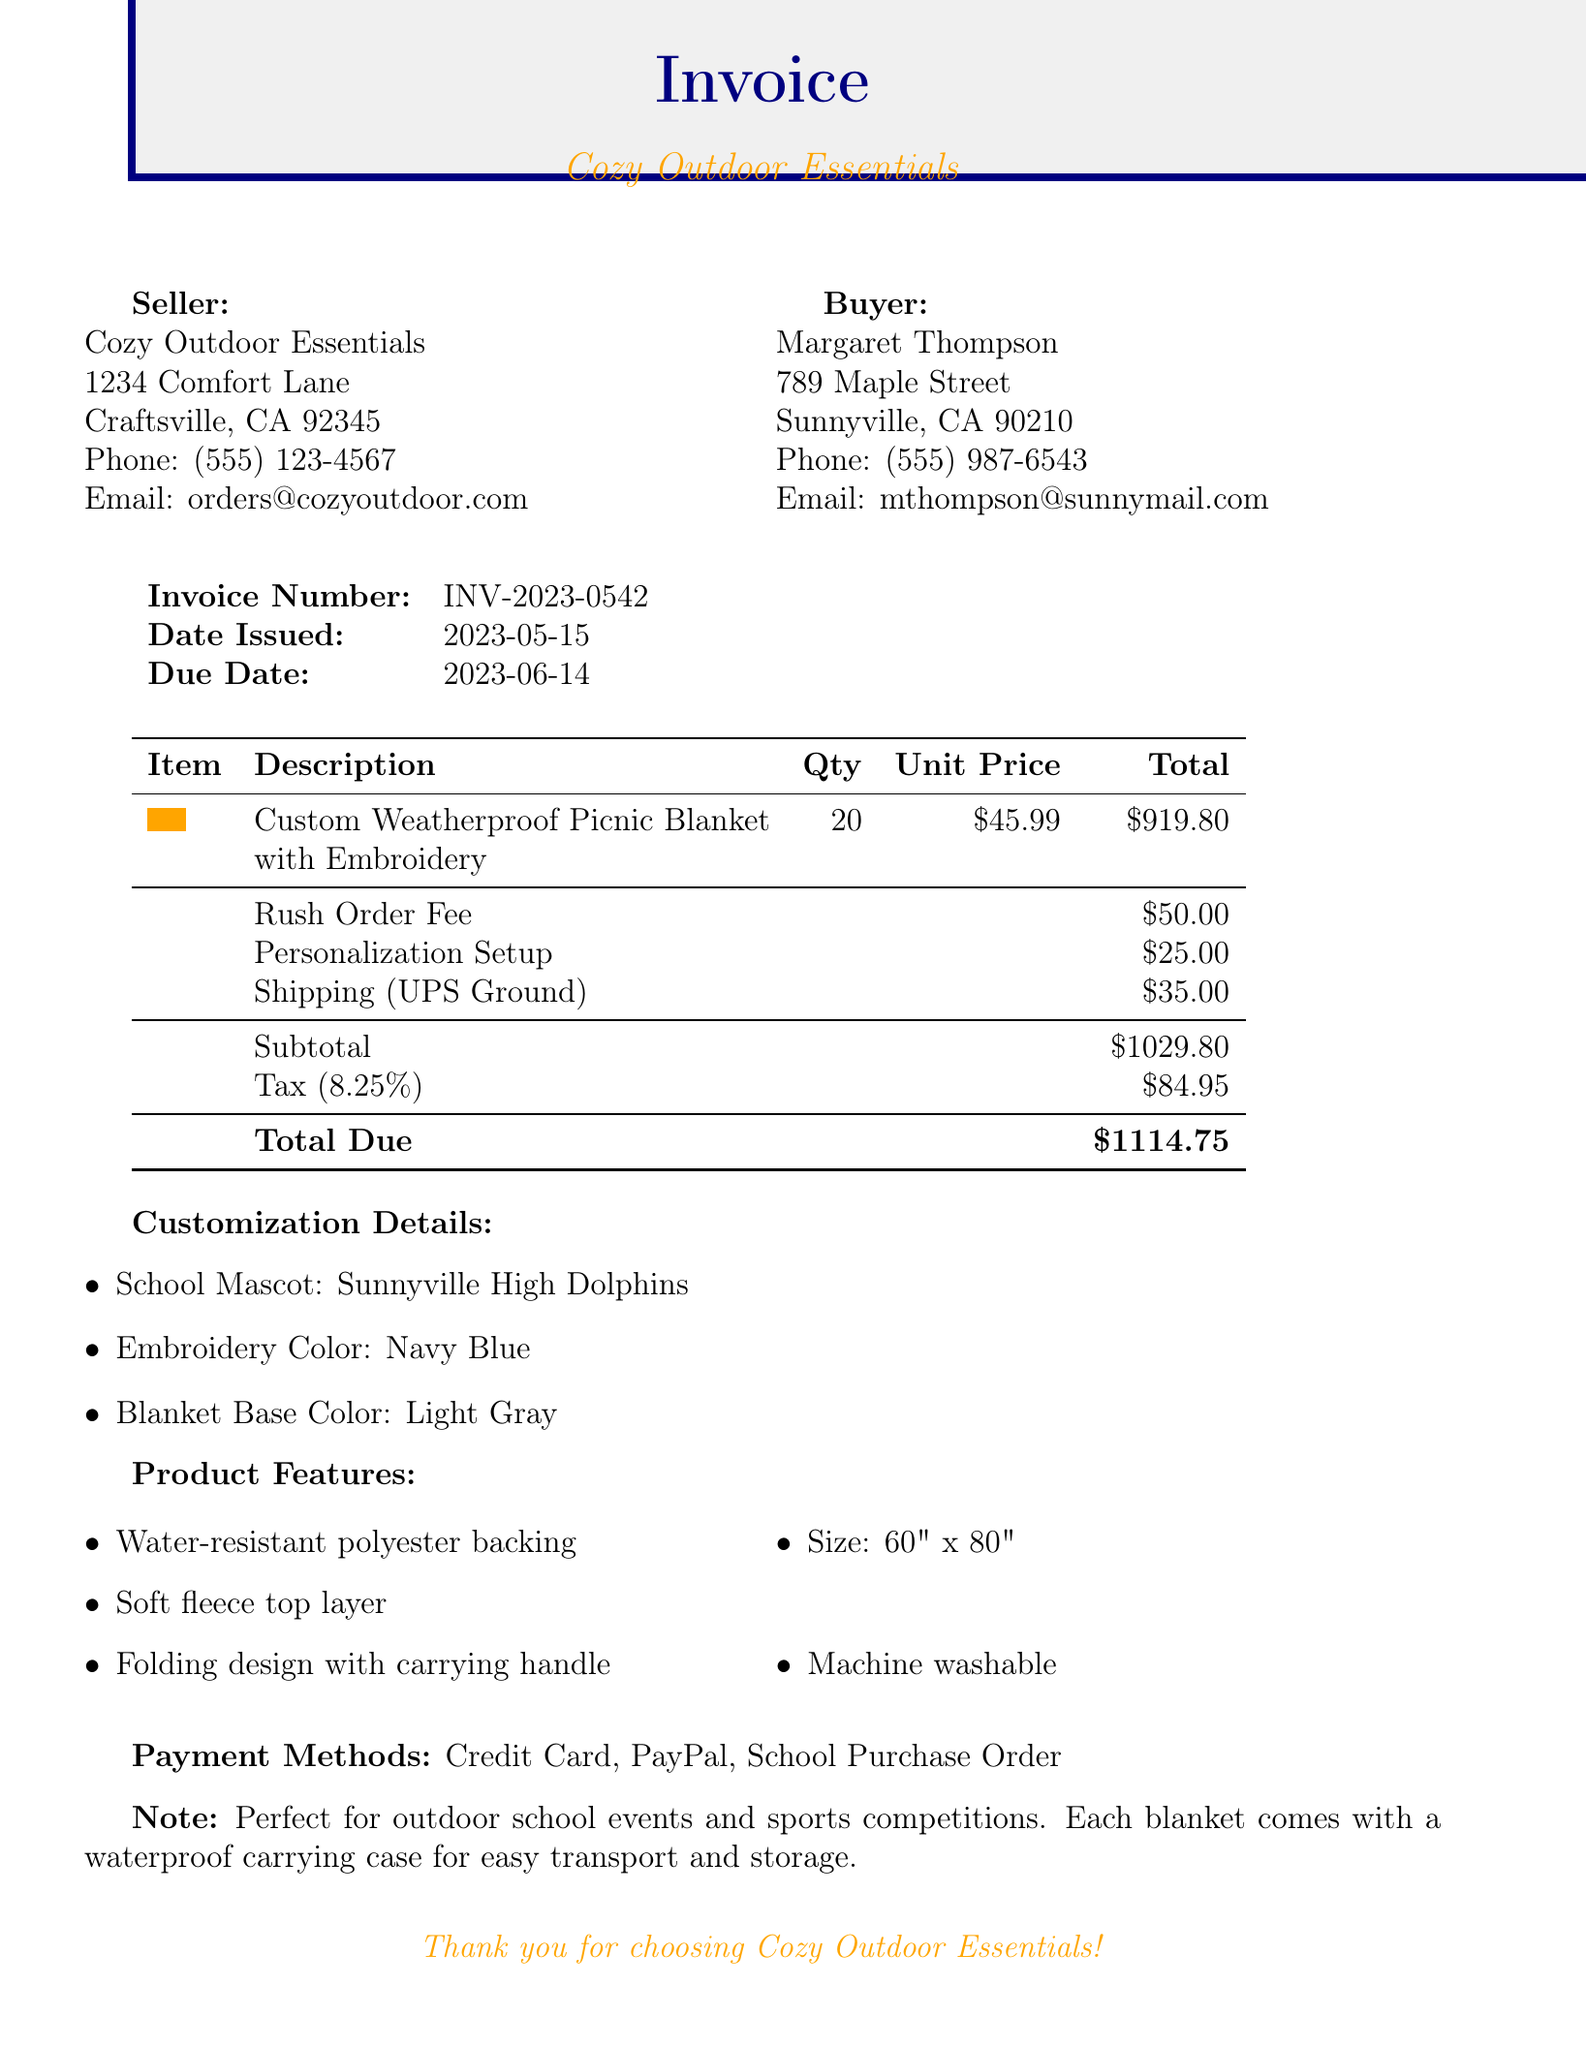What is the invoice number? The invoice number is specified in the document under invoice details.
Answer: INV-2023-0542 Who is the seller? The seller is identified in the seller information section.
Answer: Cozy Outdoor Essentials What is the due date for the invoice? The due date is indicated in the invoice details.
Answer: 2023-06-14 How many picnic blankets were ordered? The quantity of picnic blankets is shown in the order details section.
Answer: 20 What is the shipping method? The shipping method is specified in the shipping information.
Answer: UPS Ground What is the tax amount included in the total due? The tax amount is detailed in the payment details section of the document.
Answer: 84.95 What color is the blanket base? The blanket base color is listed in the customization details.
Answer: Light Gray What is the total due amount? The total due is summarized in the payment details.
Answer: 1114.75 What is the additional service fee for the rush order? The rush order fee is mentioned in the additional services section.
Answer: 50.00 